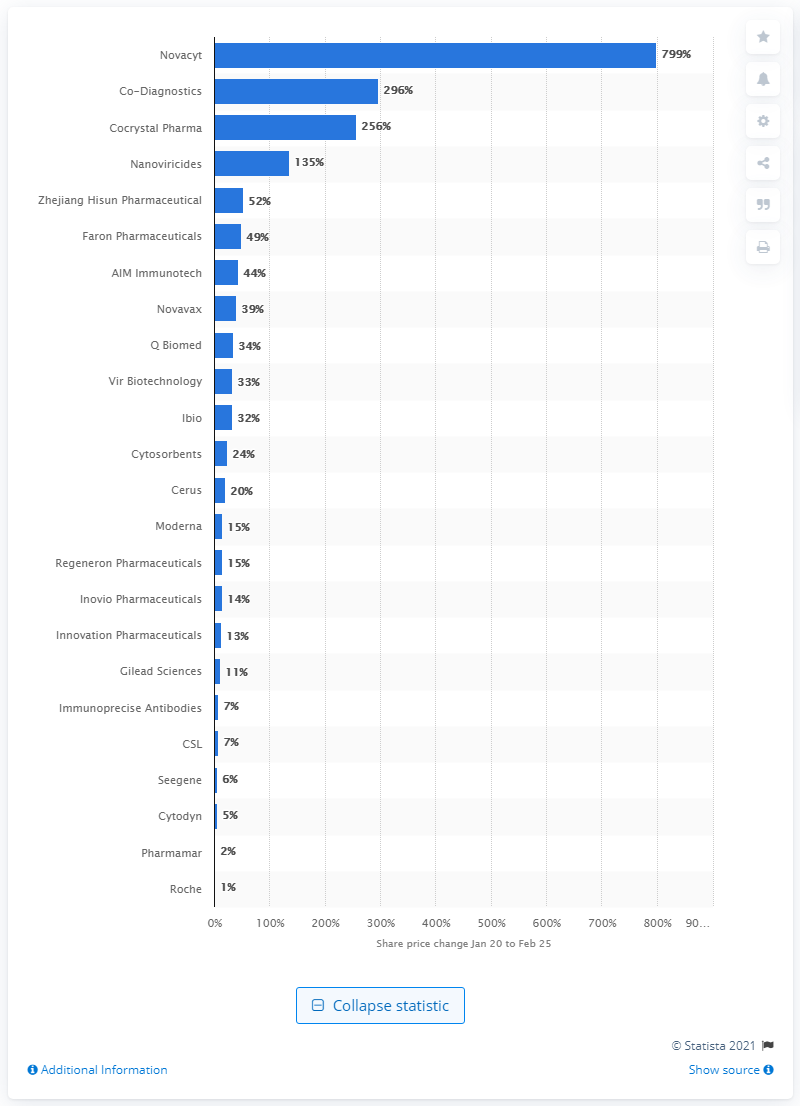Mention a couple of crucial points in this snapshot. On January 20 and February 25, 2020, the share prices of Novacyt and Co-Diagnostics rose by 799%. 